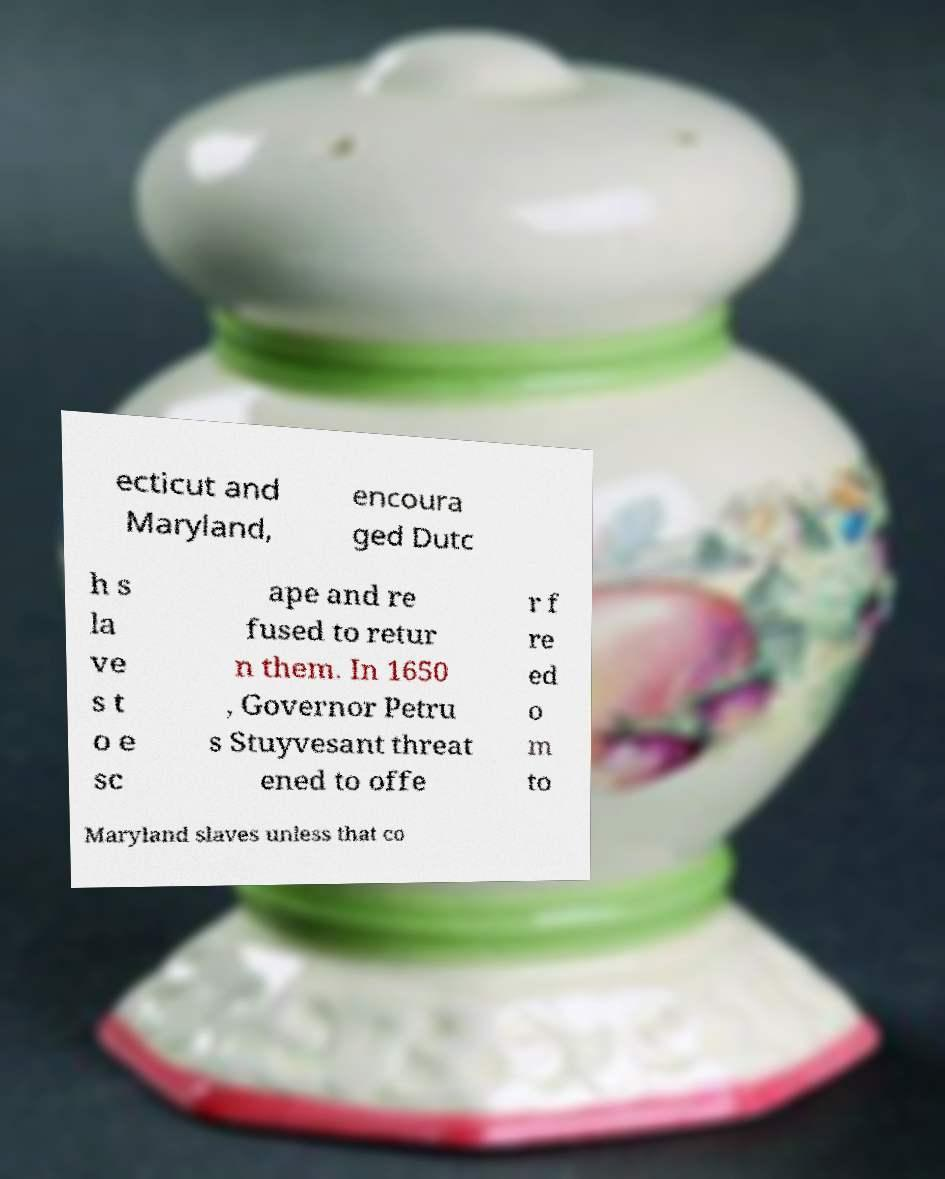For documentation purposes, I need the text within this image transcribed. Could you provide that? ecticut and Maryland, encoura ged Dutc h s la ve s t o e sc ape and re fused to retur n them. In 1650 , Governor Petru s Stuyvesant threat ened to offe r f re ed o m to Maryland slaves unless that co 